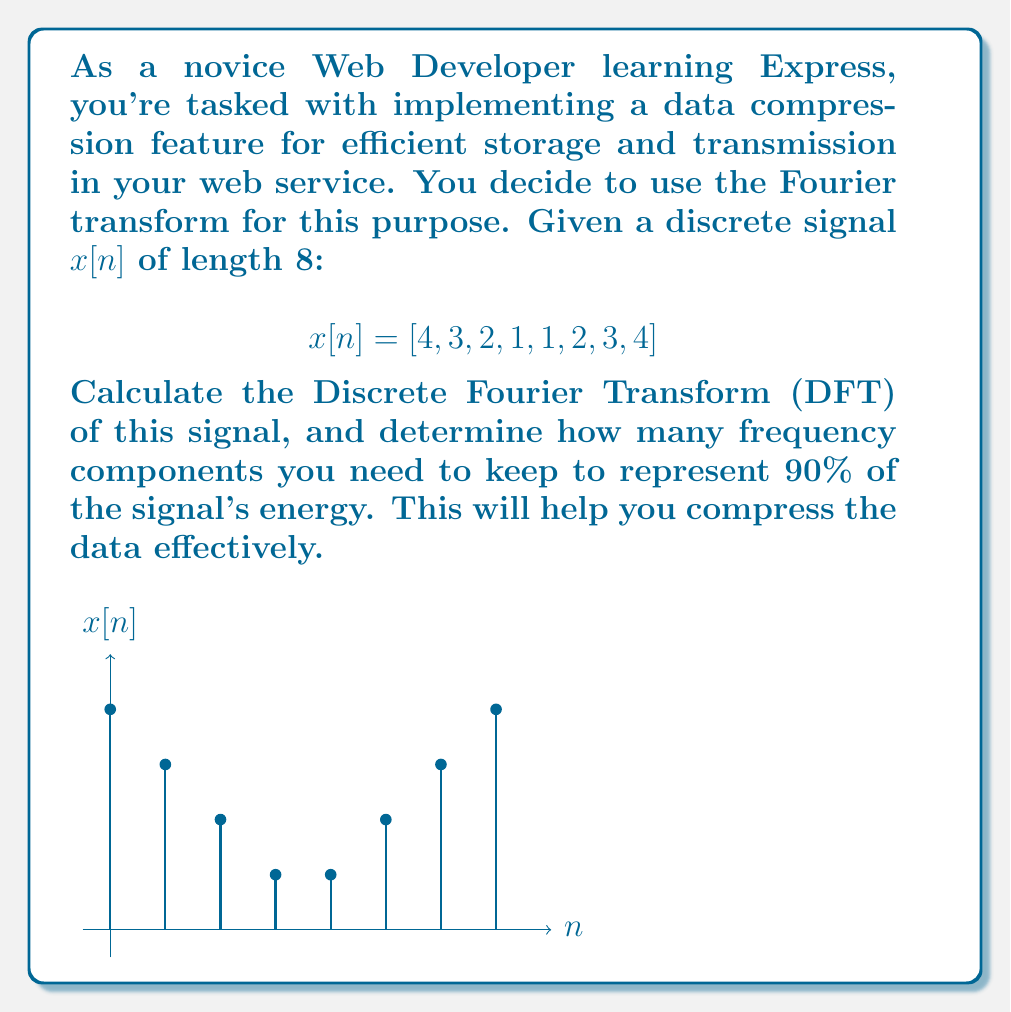Could you help me with this problem? Let's approach this step-by-step:

1) First, we need to calculate the DFT of the signal. The DFT is given by:

   $$X[k] = \sum_{n=0}^{N-1} x[n] e^{-j2\pi kn/N}$$

   where $N=8$ is the length of the signal.

2) Calculating this for $k=0,1,\ldots,7$, we get:

   $$X[k] = [20, -2.83-2.83j, 0, -1.17+1.17j, 0, -1.17-1.17j, 0, -2.83+2.83j]$$

3) The energy of each frequency component is given by $|X[k]|^2$:

   $$|X[k]|^2 = [400, 16, 0, 2.74, 0, 2.74, 0, 16]$$

4) The total energy of the signal is the sum of these values:

   $$E_{total} = 437.48$$

5) To find how many components we need for 90% of the energy, we sort these values in descending order and sum them until we reach 90% of the total energy:

   400 (91.4% of total energy)

6) We see that just the DC component (k=0) already accounts for more than 90% of the signal's energy.

Therefore, to represent 90% of the signal's energy, we only need to keep 1 frequency component.
Answer: 1 frequency component 